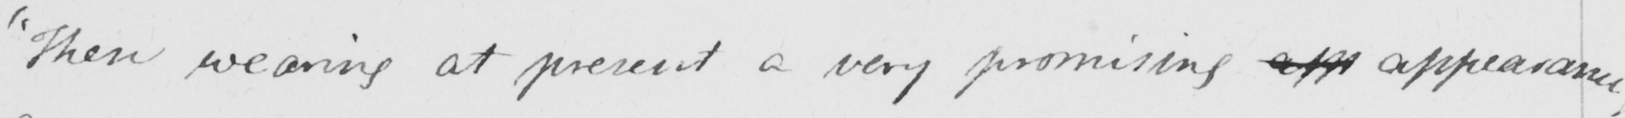Please transcribe the handwritten text in this image. " Then wearing at present a very promising app appearance , 